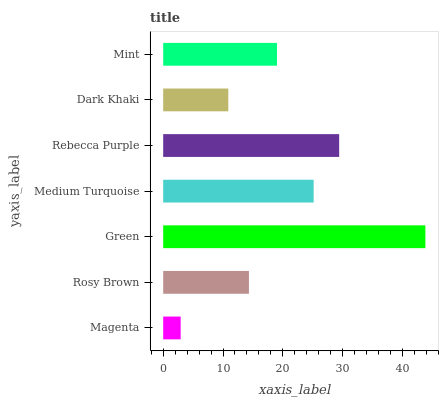Is Magenta the minimum?
Answer yes or no. Yes. Is Green the maximum?
Answer yes or no. Yes. Is Rosy Brown the minimum?
Answer yes or no. No. Is Rosy Brown the maximum?
Answer yes or no. No. Is Rosy Brown greater than Magenta?
Answer yes or no. Yes. Is Magenta less than Rosy Brown?
Answer yes or no. Yes. Is Magenta greater than Rosy Brown?
Answer yes or no. No. Is Rosy Brown less than Magenta?
Answer yes or no. No. Is Mint the high median?
Answer yes or no. Yes. Is Mint the low median?
Answer yes or no. Yes. Is Medium Turquoise the high median?
Answer yes or no. No. Is Medium Turquoise the low median?
Answer yes or no. No. 